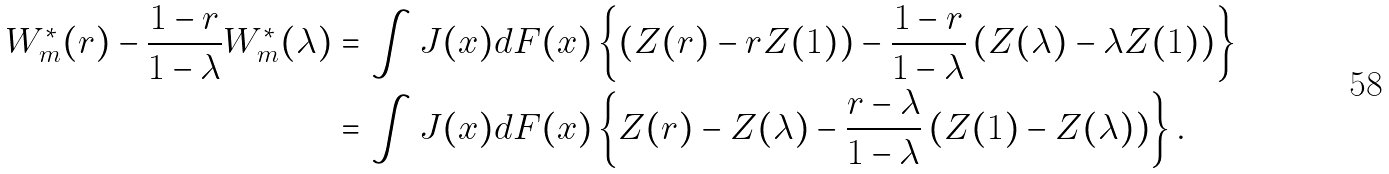<formula> <loc_0><loc_0><loc_500><loc_500>W _ { m } ^ { * } ( r ) - \frac { 1 - r } { 1 - \lambda } W _ { m } ^ { * } ( \lambda ) & = \int J ( x ) d F ( x ) \left \{ \left ( Z ( r ) - r Z ( 1 ) \right ) - \frac { 1 - r } { 1 - \lambda } \left ( Z ( \lambda ) - \lambda Z ( 1 ) \right ) \right \} \\ & = \int J ( x ) d F ( x ) \left \{ Z ( r ) - Z ( \lambda ) - \frac { r - \lambda } { 1 - \lambda } \left ( Z ( 1 ) - Z ( \lambda ) \right ) \right \} .</formula> 